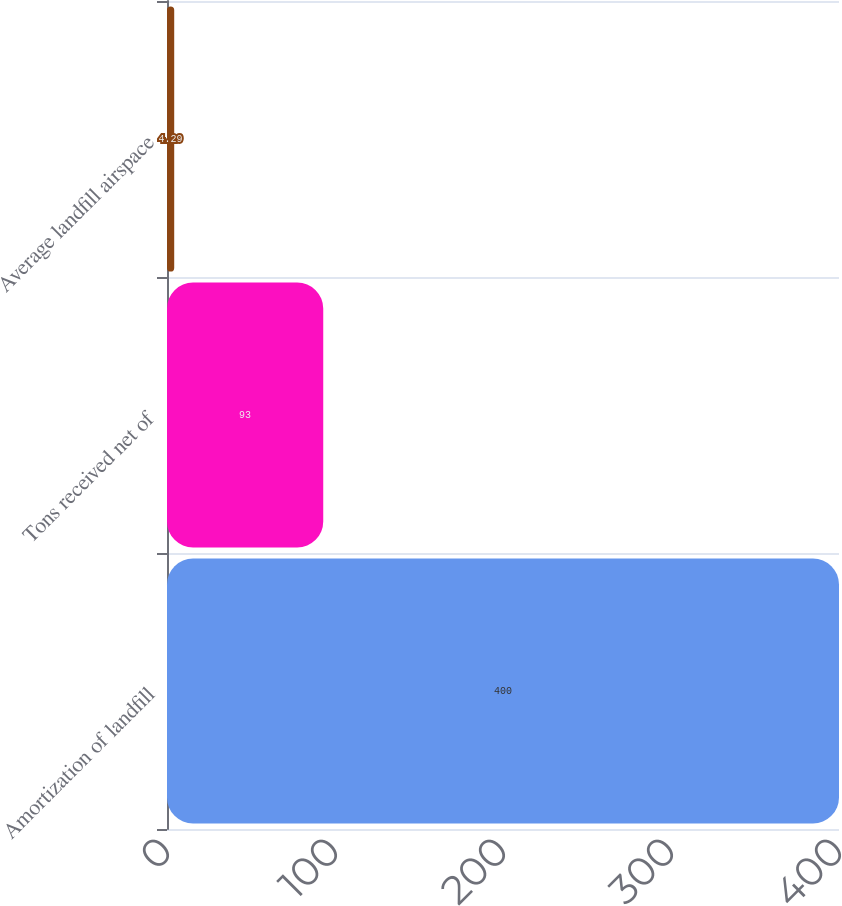<chart> <loc_0><loc_0><loc_500><loc_500><bar_chart><fcel>Amortization of landfill<fcel>Tons received net of<fcel>Average landfill airspace<nl><fcel>400<fcel>93<fcel>4.29<nl></chart> 